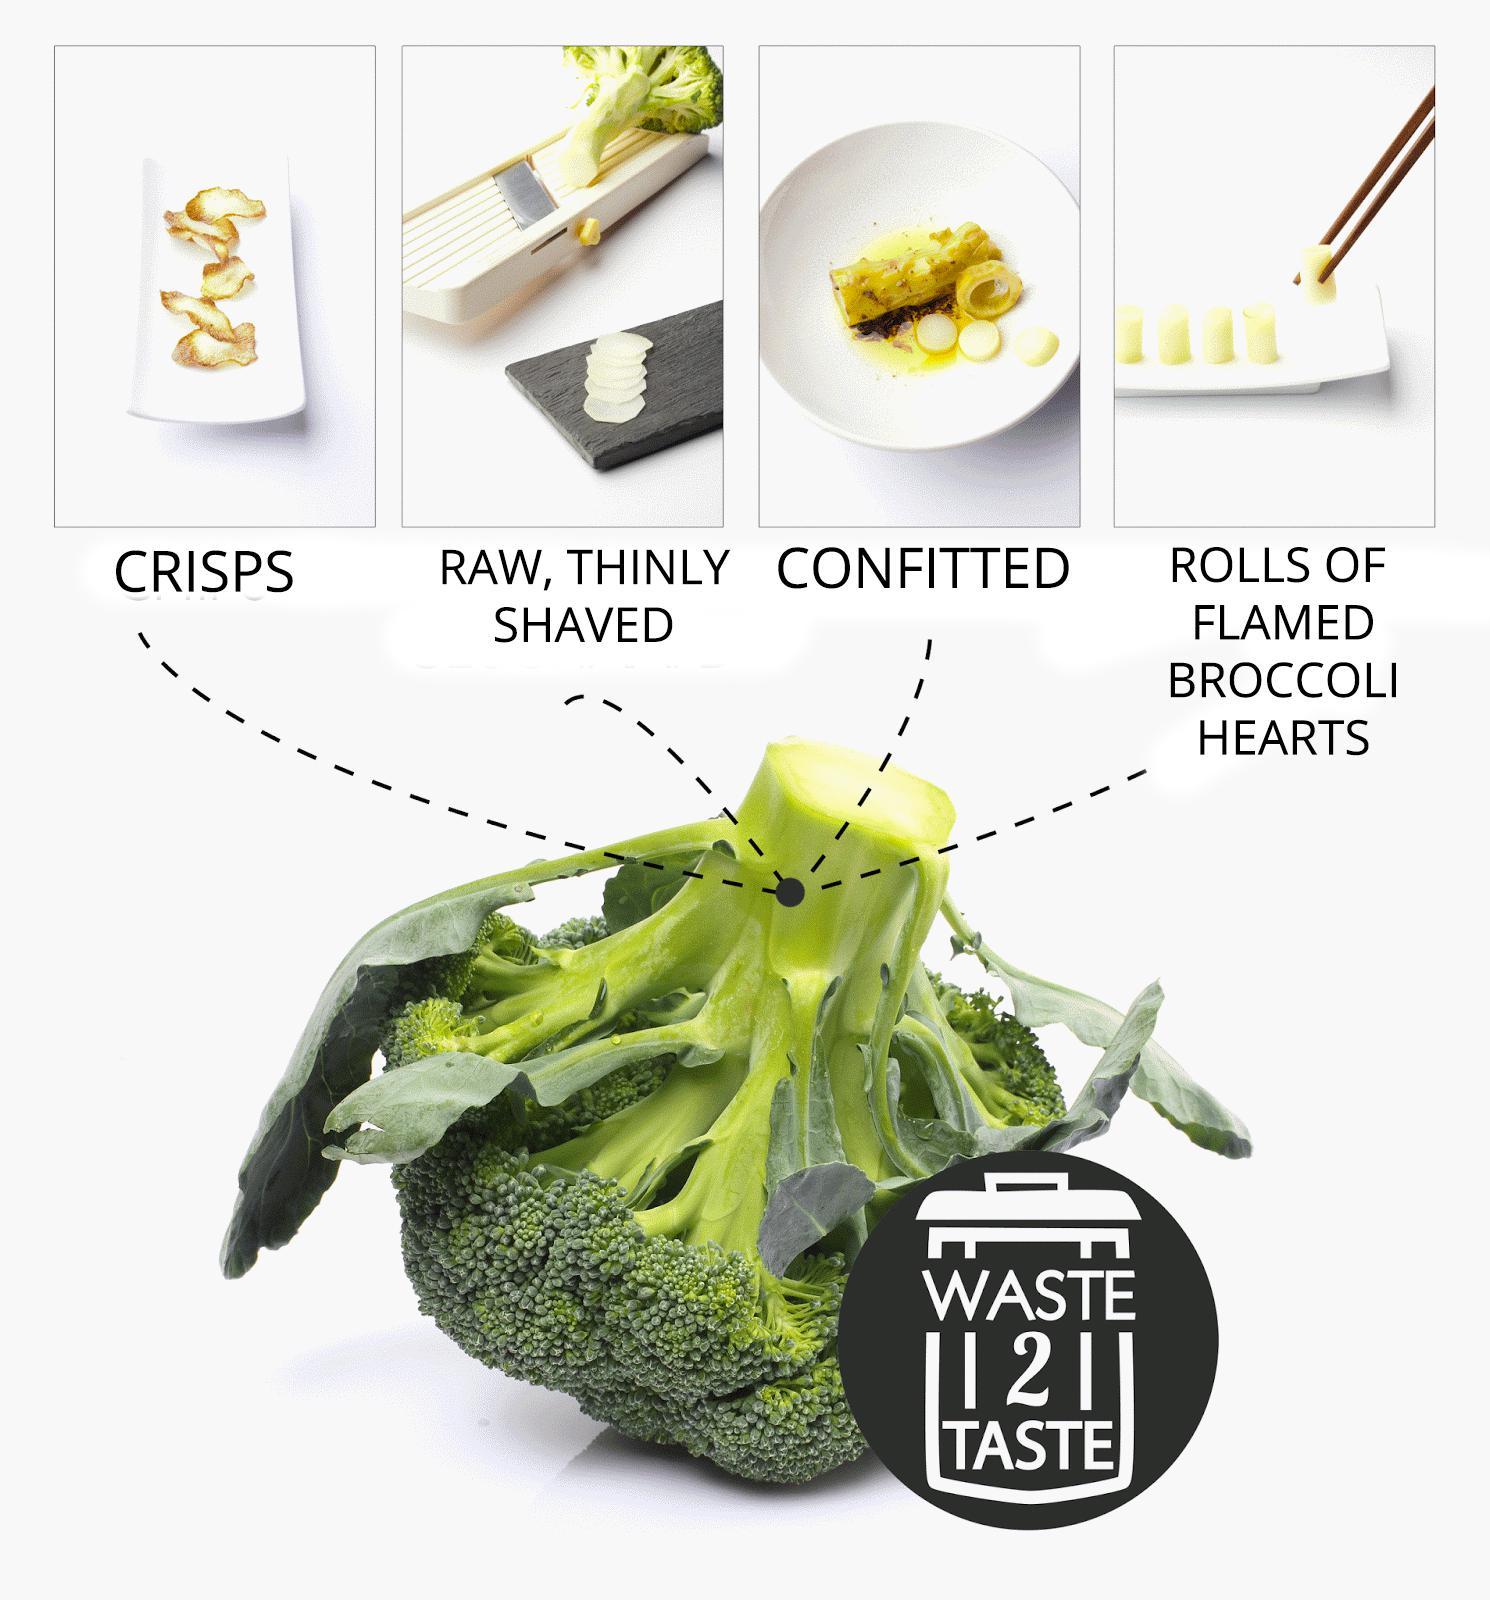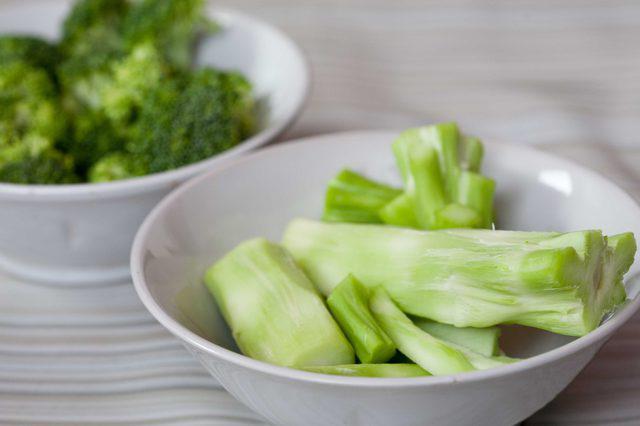The first image is the image on the left, the second image is the image on the right. Examine the images to the left and right. Is the description "The broccoli in the image on the right is in a white bowl." accurate? Answer yes or no. Yes. The first image is the image on the left, the second image is the image on the right. For the images shown, is this caption "An image includes a white bowl that contains multiple broccoli florets." true? Answer yes or no. Yes. The first image is the image on the left, the second image is the image on the right. Analyze the images presented: Is the assertion "Brocolli sits in a white bowl in the image on the right." valid? Answer yes or no. Yes. The first image is the image on the left, the second image is the image on the right. Evaluate the accuracy of this statement regarding the images: "An image shows a white bowl that contains some broccoli stalks.". Is it true? Answer yes or no. Yes. 